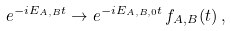<formula> <loc_0><loc_0><loc_500><loc_500>e ^ { - i E _ { A , B } t } \rightarrow e ^ { - i E _ { A , B , 0 } t } \, f _ { A , B } ( t ) \, ,</formula> 